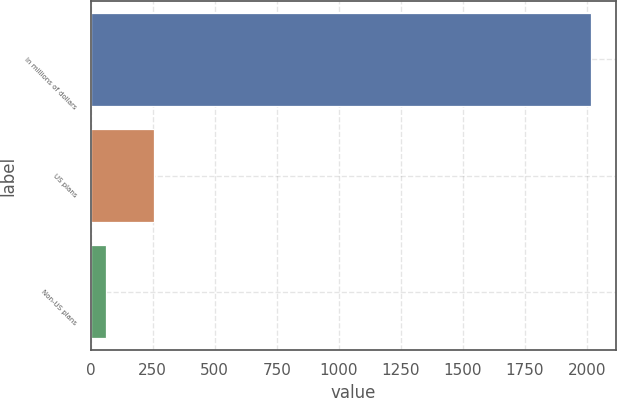Convert chart to OTSL. <chart><loc_0><loc_0><loc_500><loc_500><bar_chart><fcel>In millions of dollars<fcel>US plans<fcel>Non-US plans<nl><fcel>2016<fcel>256.5<fcel>61<nl></chart> 